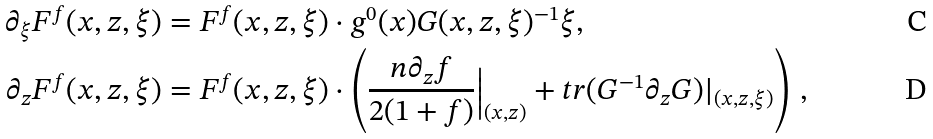Convert formula to latex. <formula><loc_0><loc_0><loc_500><loc_500>\partial _ { \xi } F ^ { f } ( x , z , \xi ) & = F ^ { f } ( x , z , \xi ) \cdot g ^ { 0 } ( x ) G ( x , z , \xi ) ^ { - 1 } \xi , \\ \partial _ { z } F ^ { f } ( x , z , \xi ) & = F ^ { f } ( x , z , \xi ) \cdot \left ( \frac { n \partial _ { z } f } { 2 ( 1 + f ) } \Big | _ { ( x , z ) } + t r ( G ^ { - 1 } \partial _ { z } G ) | _ { ( x , z , \xi ) } \right ) \, ,</formula> 